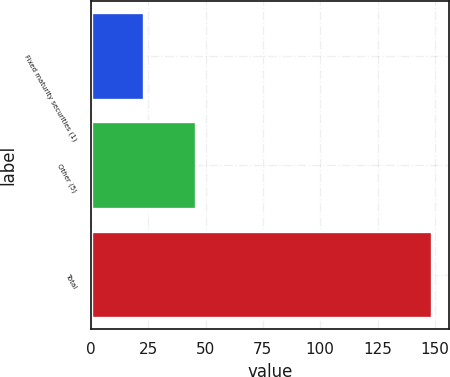Convert chart. <chart><loc_0><loc_0><loc_500><loc_500><bar_chart><fcel>Fixed maturity securities (1)<fcel>Other (5)<fcel>Total<nl><fcel>23.1<fcel>46<fcel>148.7<nl></chart> 